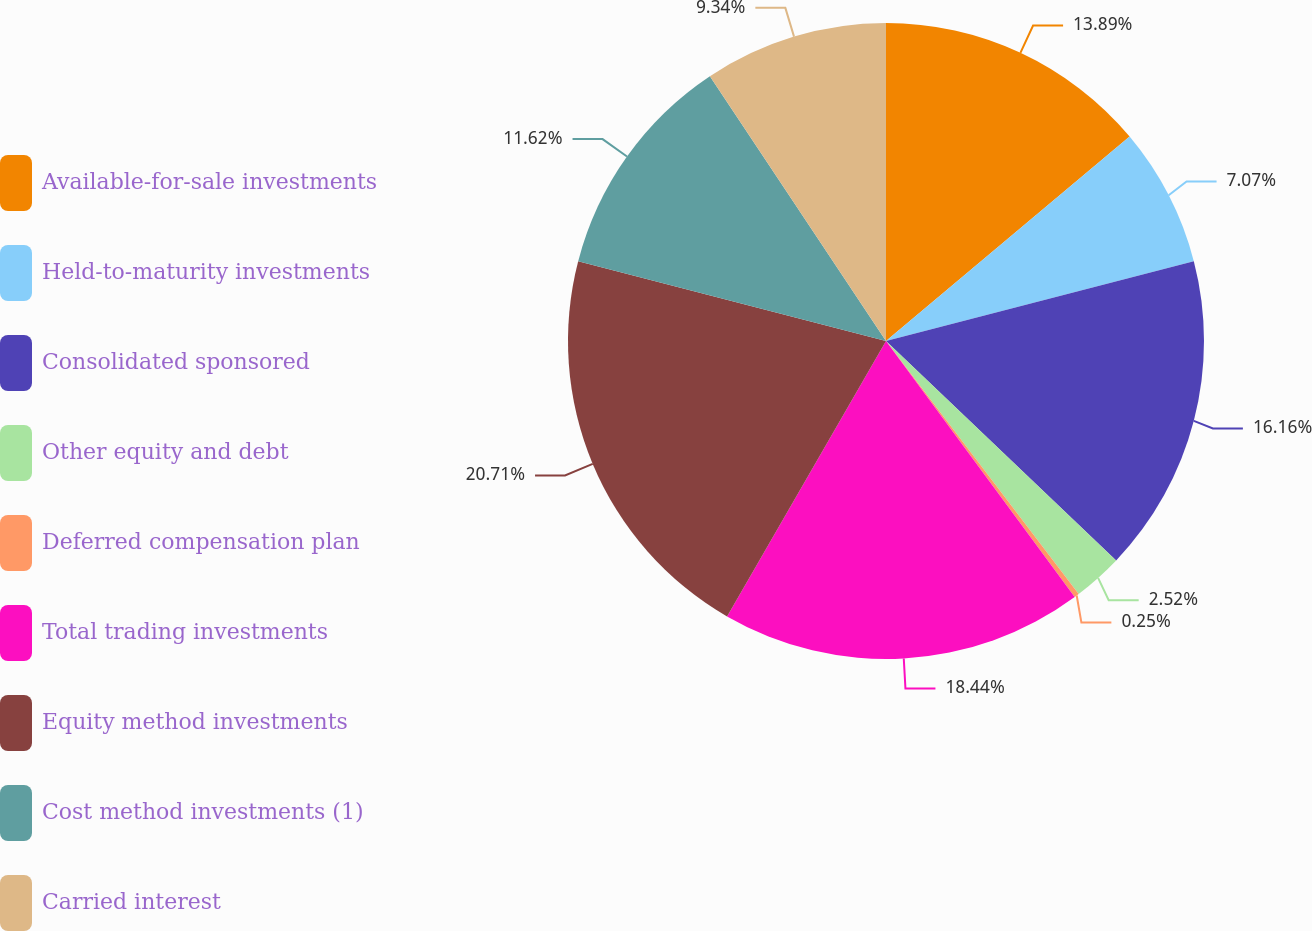<chart> <loc_0><loc_0><loc_500><loc_500><pie_chart><fcel>Available-for-sale investments<fcel>Held-to-maturity investments<fcel>Consolidated sponsored<fcel>Other equity and debt<fcel>Deferred compensation plan<fcel>Total trading investments<fcel>Equity method investments<fcel>Cost method investments (1)<fcel>Carried interest<nl><fcel>13.89%<fcel>7.07%<fcel>16.16%<fcel>2.52%<fcel>0.25%<fcel>18.44%<fcel>20.71%<fcel>11.62%<fcel>9.34%<nl></chart> 